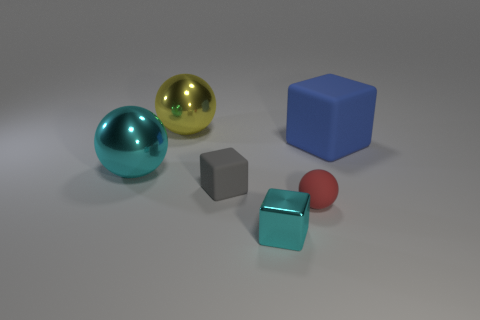Add 3 cyan metallic objects. How many objects exist? 9 Subtract all large shiny spheres. How many spheres are left? 1 Add 4 big metal balls. How many big metal balls are left? 6 Add 1 large purple shiny cylinders. How many large purple shiny cylinders exist? 1 Subtract 0 cyan cylinders. How many objects are left? 6 Subtract all gray objects. Subtract all large shiny things. How many objects are left? 3 